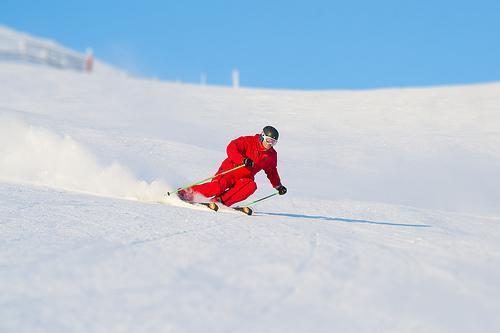How many people are there?
Give a very brief answer. 1. 